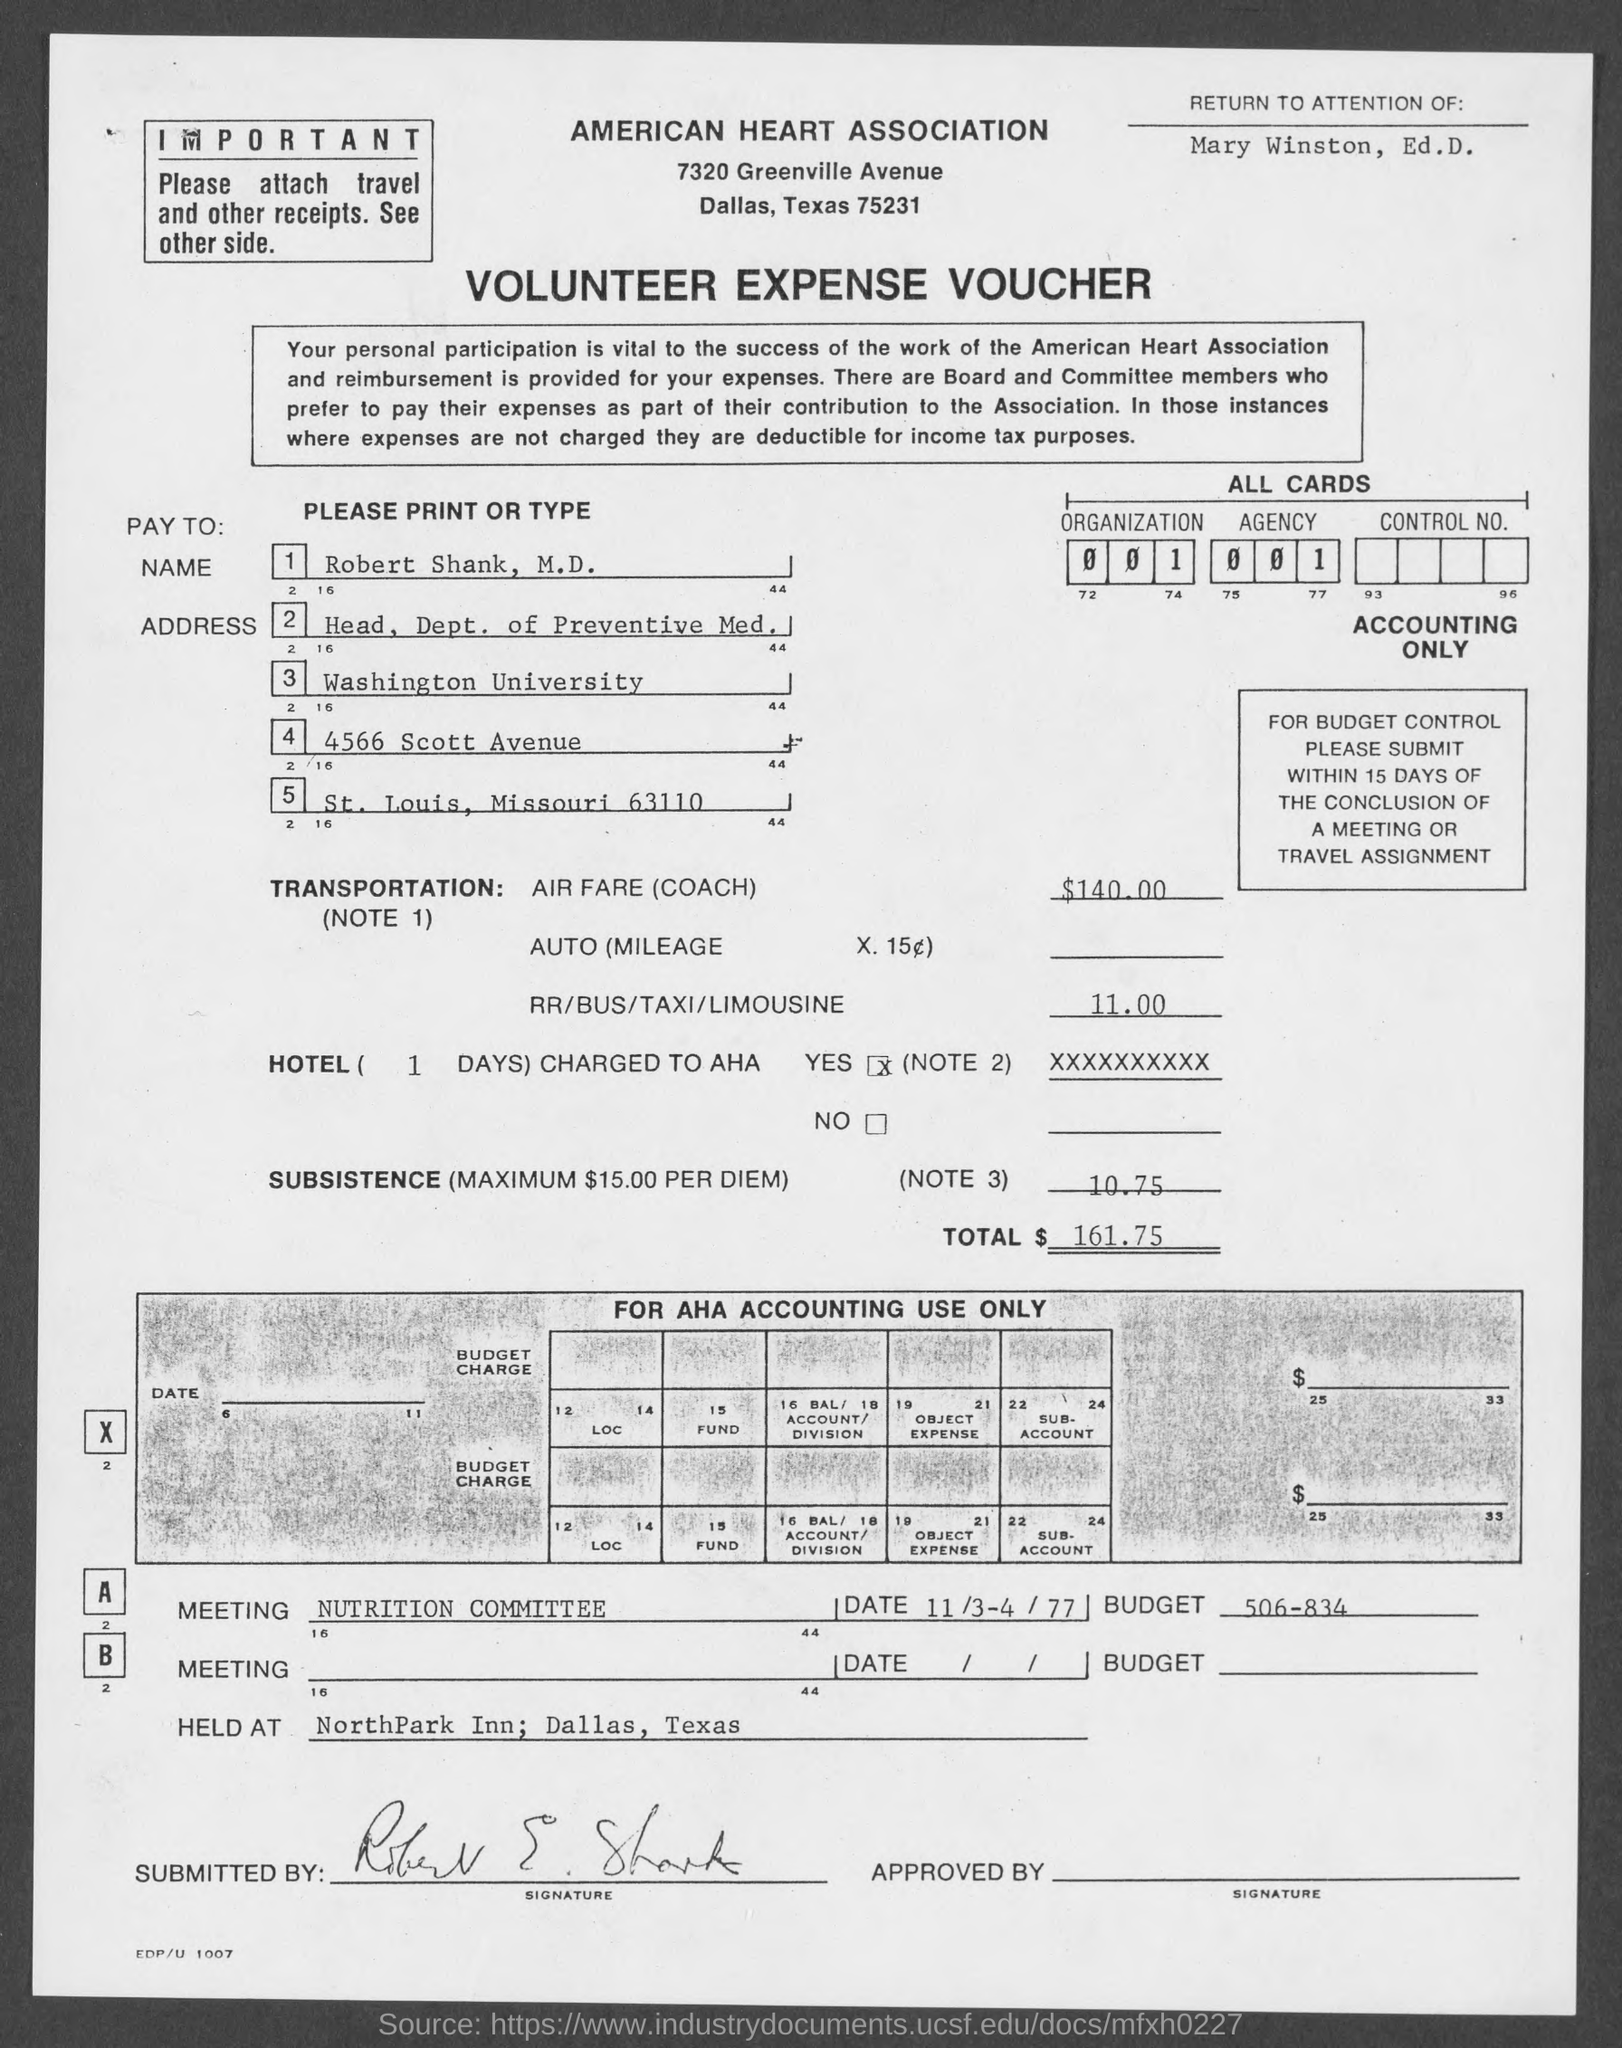What is the Title of the document?
Keep it short and to the point. Volunteer Expense Voucher. What is the Name?
Make the answer very short. Robert Shank. What is the Air fare?
Give a very brief answer. $140.00. What is the fare for RR/BUS/TAXI/LIMOUSINE?
Your answer should be compact. 11.00. What is the Subsistence?
Your response must be concise. 10.75. What is the Total?
Provide a short and direct response. $161.75. 